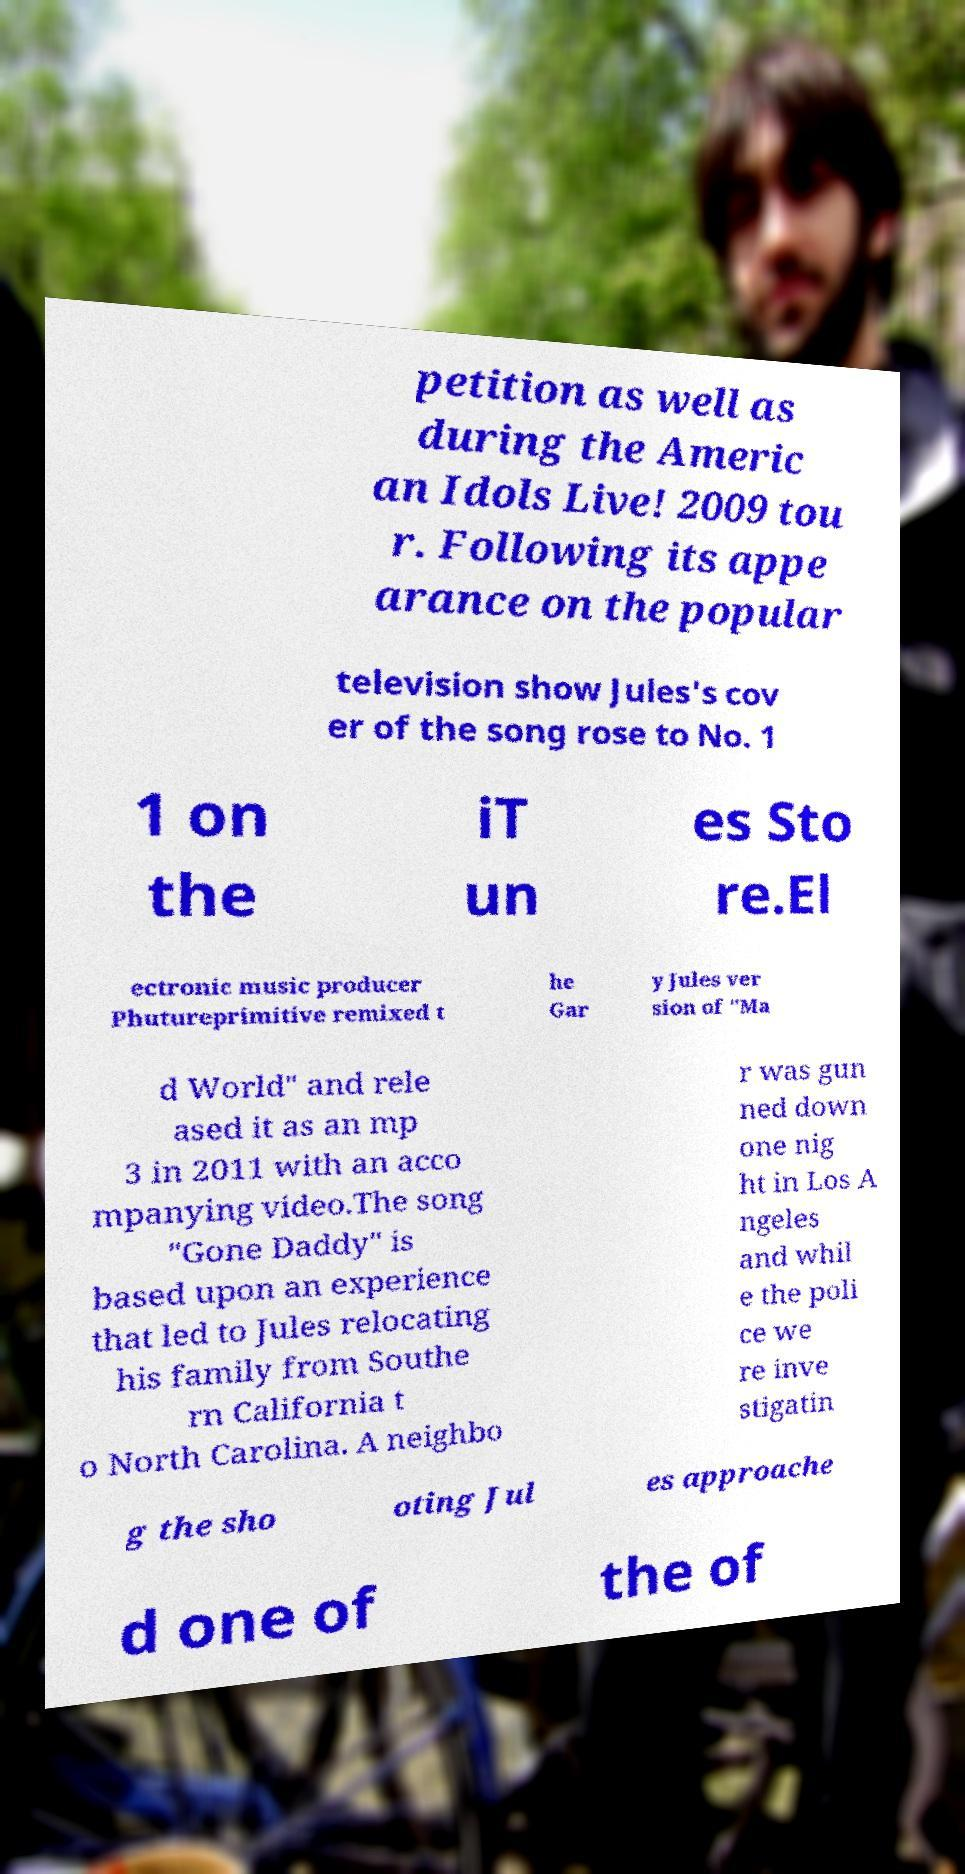For documentation purposes, I need the text within this image transcribed. Could you provide that? petition as well as during the Americ an Idols Live! 2009 tou r. Following its appe arance on the popular television show Jules's cov er of the song rose to No. 1 1 on the iT un es Sto re.El ectronic music producer Phutureprimitive remixed t he Gar y Jules ver sion of "Ma d World" and rele ased it as an mp 3 in 2011 with an acco mpanying video.The song "Gone Daddy" is based upon an experience that led to Jules relocating his family from Southe rn California t o North Carolina. A neighbo r was gun ned down one nig ht in Los A ngeles and whil e the poli ce we re inve stigatin g the sho oting Jul es approache d one of the of 